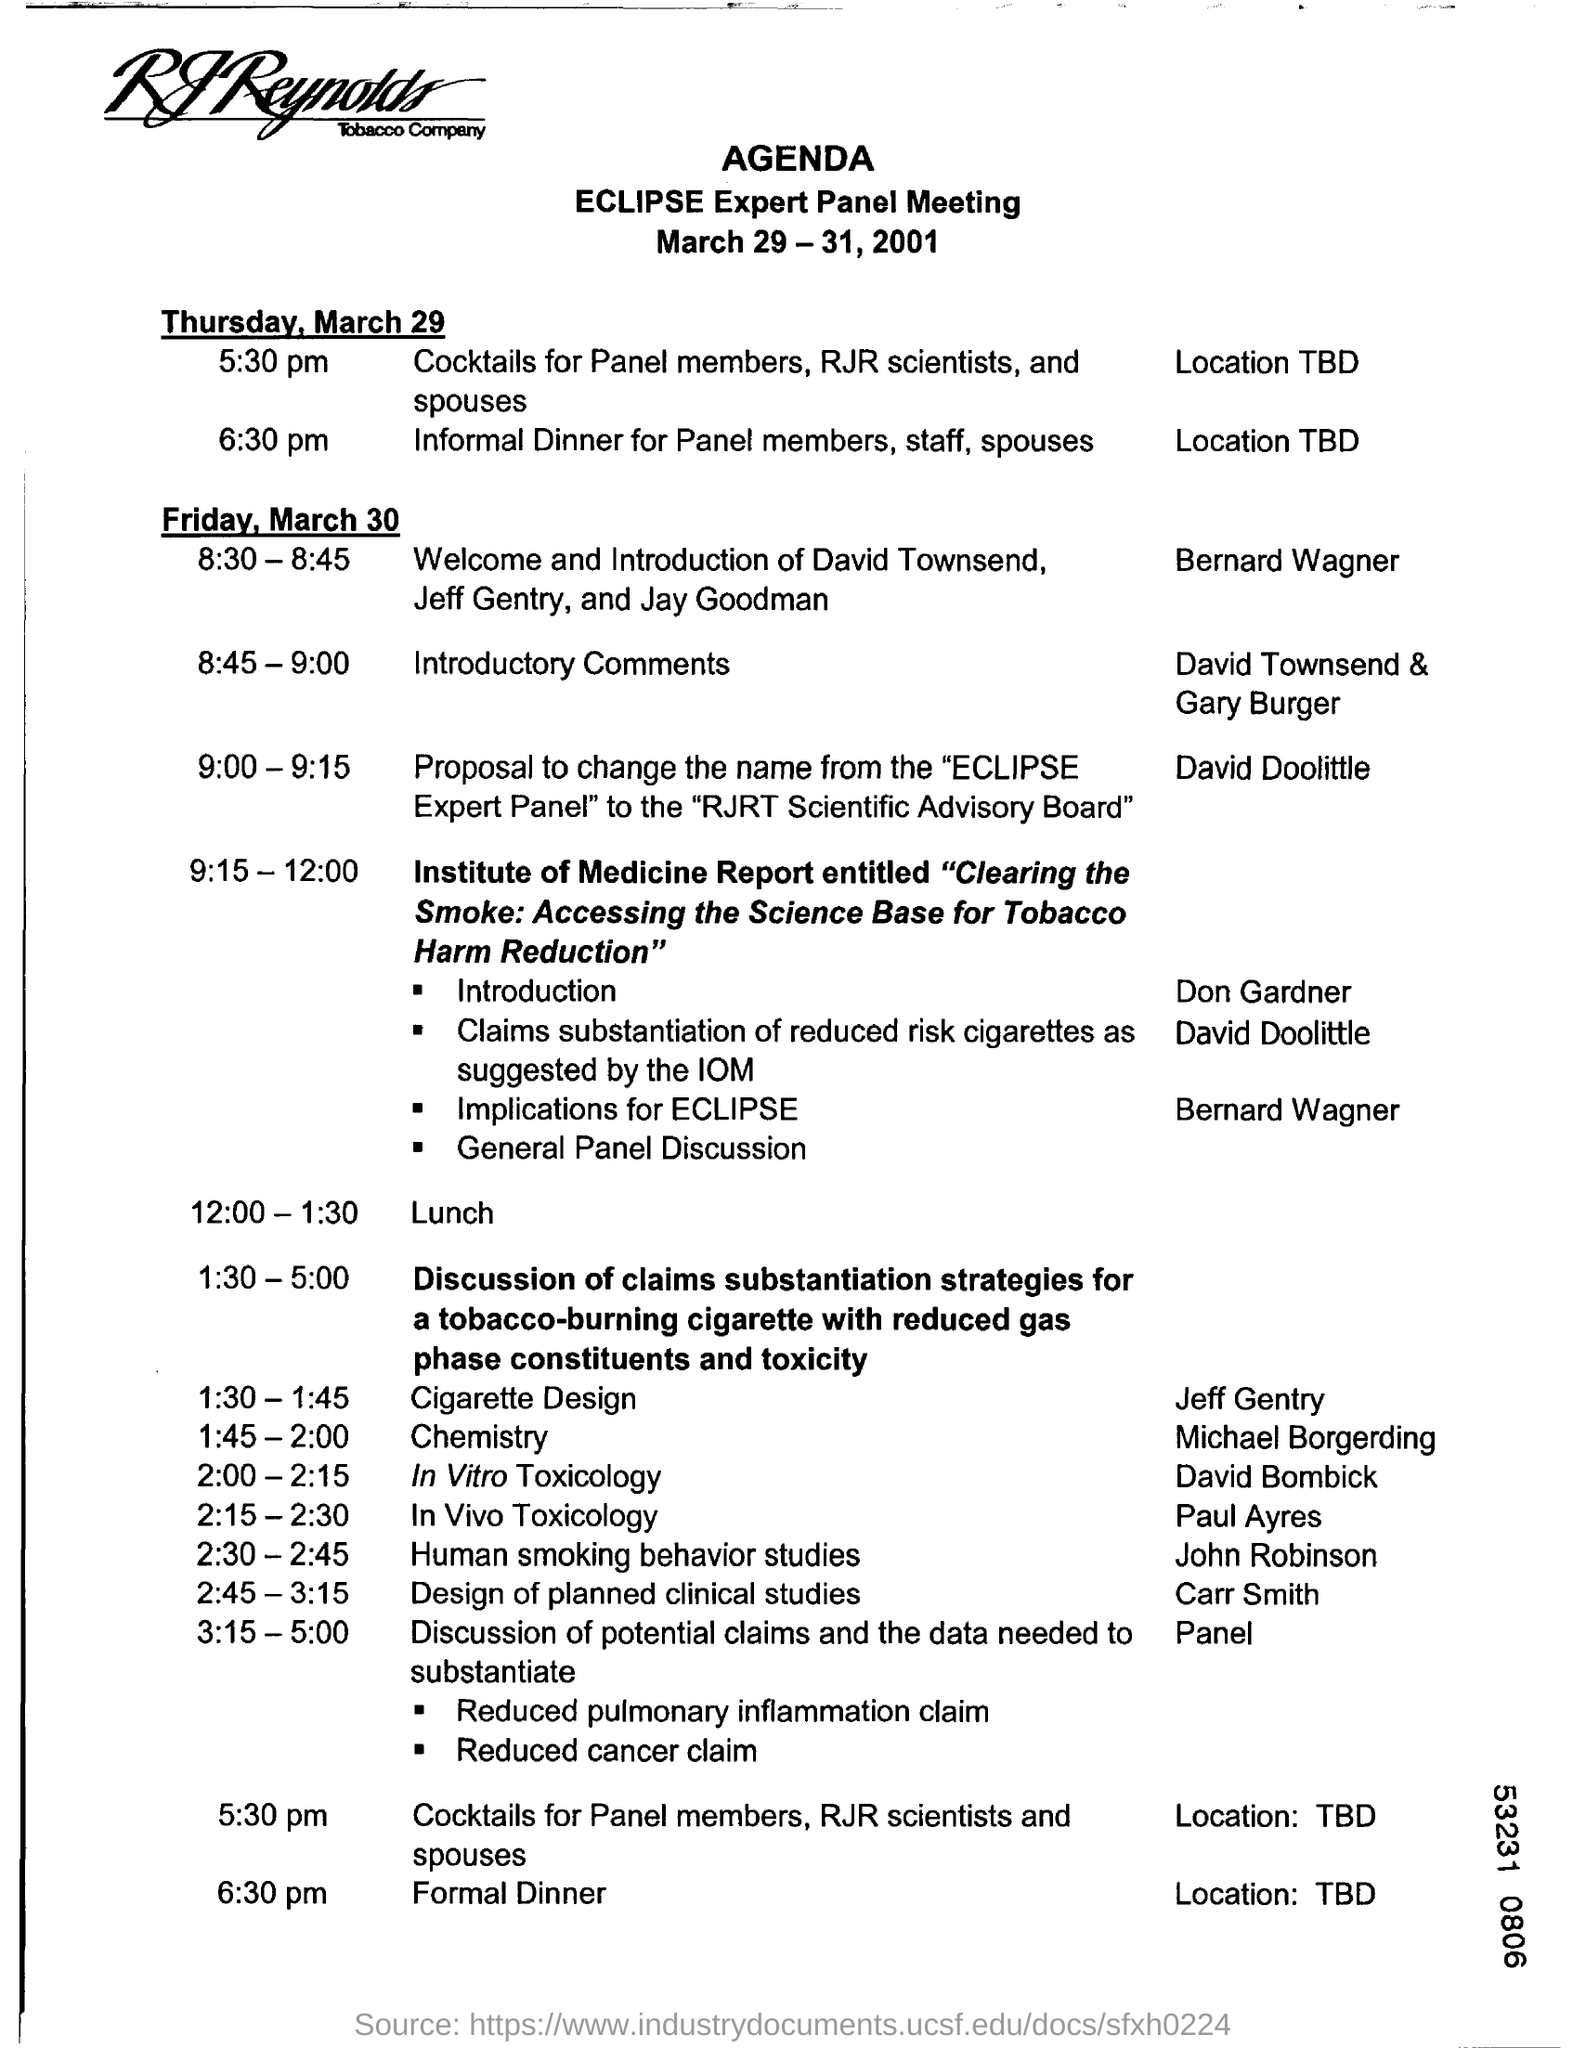When is the ECLIPSE Expert panel meeting going to be held?
Offer a terse response. 9:00 - 9:15. At what time cocktails for panel members,RJR scientists and spouses will be held.
Offer a very short reply. 5:30 pm. What is the time of informal dinner for panel members, staff, spouses on 29 march.
Provide a succinct answer. 6:30 pm. Who  is giving welcome and introduction of david townsend,jeff gentry and jay goodman?
Your answer should be very brief. Bernard Wagner. What proposal  is David Doolittle giving.
Ensure brevity in your answer.  Proposal to change the name from "eclipse expert panel" to "rjrt scientific advisory board". What is the time of david doolittle proposal?
Give a very brief answer. 9:00-9:15. What is the time for lunch break?
Your response must be concise. 12:00-1:30. What is the time for discussing human smoking behavior studies?
Your answer should be compact. 2:30 - 2:45. Who is discussing the human smoking behavior studies?
Your answer should be very brief. John Robinson. 